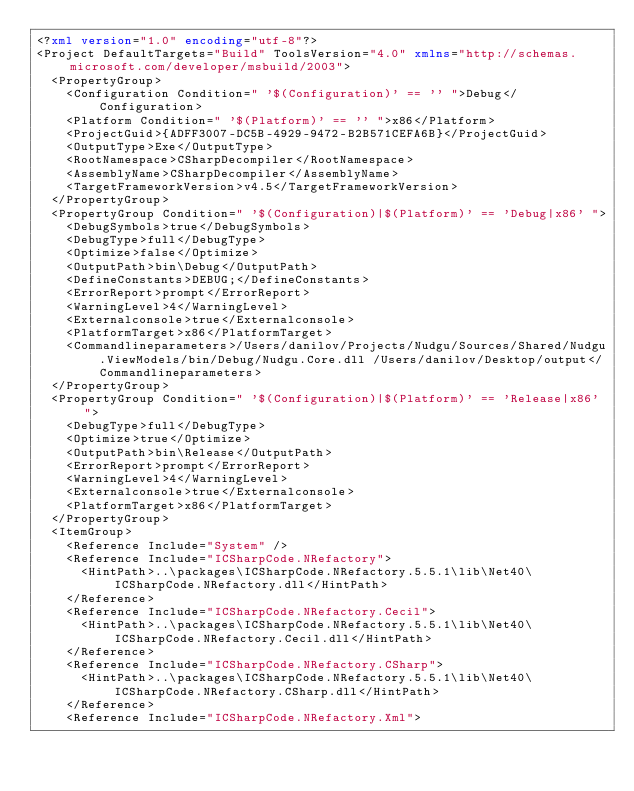Convert code to text. <code><loc_0><loc_0><loc_500><loc_500><_XML_><?xml version="1.0" encoding="utf-8"?>
<Project DefaultTargets="Build" ToolsVersion="4.0" xmlns="http://schemas.microsoft.com/developer/msbuild/2003">
  <PropertyGroup>
    <Configuration Condition=" '$(Configuration)' == '' ">Debug</Configuration>
    <Platform Condition=" '$(Platform)' == '' ">x86</Platform>
    <ProjectGuid>{ADFF3007-DC5B-4929-9472-B2B571CEFA6B}</ProjectGuid>
    <OutputType>Exe</OutputType>
    <RootNamespace>CSharpDecompiler</RootNamespace>
    <AssemblyName>CSharpDecompiler</AssemblyName>
    <TargetFrameworkVersion>v4.5</TargetFrameworkVersion>
  </PropertyGroup>
  <PropertyGroup Condition=" '$(Configuration)|$(Platform)' == 'Debug|x86' ">
    <DebugSymbols>true</DebugSymbols>
    <DebugType>full</DebugType>
    <Optimize>false</Optimize>
    <OutputPath>bin\Debug</OutputPath>
    <DefineConstants>DEBUG;</DefineConstants>
    <ErrorReport>prompt</ErrorReport>
    <WarningLevel>4</WarningLevel>
    <Externalconsole>true</Externalconsole>
    <PlatformTarget>x86</PlatformTarget>
    <Commandlineparameters>/Users/danilov/Projects/Nudgu/Sources/Shared/Nudgu.ViewModels/bin/Debug/Nudgu.Core.dll /Users/danilov/Desktop/output</Commandlineparameters>
  </PropertyGroup>
  <PropertyGroup Condition=" '$(Configuration)|$(Platform)' == 'Release|x86' ">
    <DebugType>full</DebugType>
    <Optimize>true</Optimize>
    <OutputPath>bin\Release</OutputPath>
    <ErrorReport>prompt</ErrorReport>
    <WarningLevel>4</WarningLevel>
    <Externalconsole>true</Externalconsole>
    <PlatformTarget>x86</PlatformTarget>
  </PropertyGroup>
  <ItemGroup>
    <Reference Include="System" />
    <Reference Include="ICSharpCode.NRefactory">
      <HintPath>..\packages\ICSharpCode.NRefactory.5.5.1\lib\Net40\ICSharpCode.NRefactory.dll</HintPath>
    </Reference>
    <Reference Include="ICSharpCode.NRefactory.Cecil">
      <HintPath>..\packages\ICSharpCode.NRefactory.5.5.1\lib\Net40\ICSharpCode.NRefactory.Cecil.dll</HintPath>
    </Reference>
    <Reference Include="ICSharpCode.NRefactory.CSharp">
      <HintPath>..\packages\ICSharpCode.NRefactory.5.5.1\lib\Net40\ICSharpCode.NRefactory.CSharp.dll</HintPath>
    </Reference>
    <Reference Include="ICSharpCode.NRefactory.Xml"></code> 